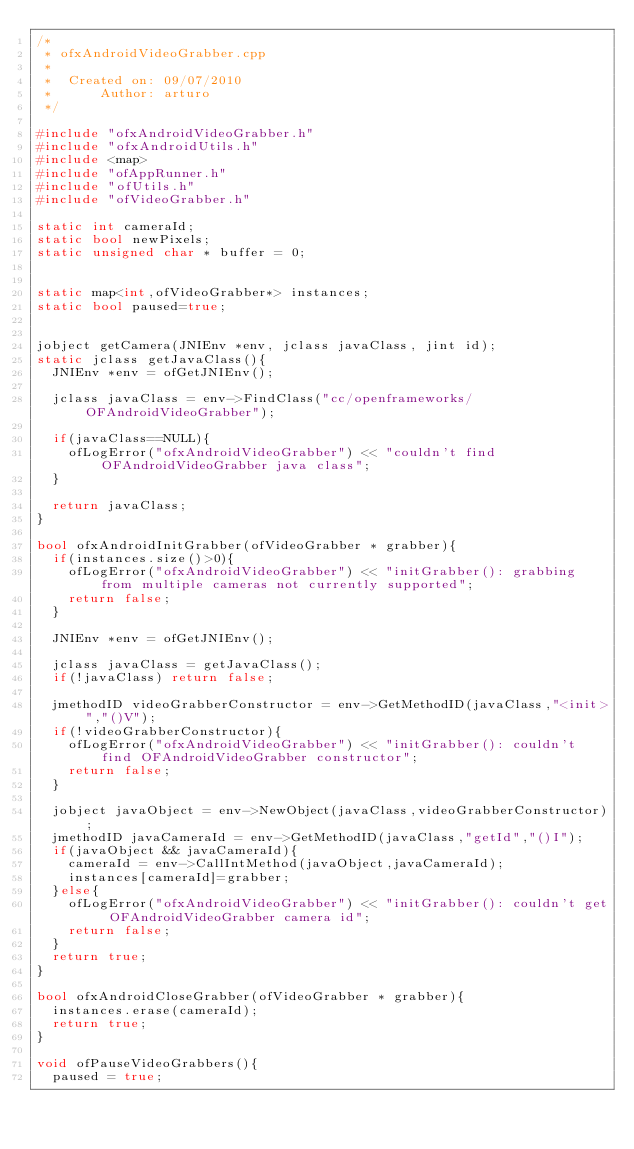Convert code to text. <code><loc_0><loc_0><loc_500><loc_500><_C++_>/*
 * ofxAndroidVideoGrabber.cpp
 *
 *  Created on: 09/07/2010
 *      Author: arturo
 */

#include "ofxAndroidVideoGrabber.h"
#include "ofxAndroidUtils.h"
#include <map>
#include "ofAppRunner.h"
#include "ofUtils.h"
#include "ofVideoGrabber.h"

static int cameraId;
static bool newPixels;
static unsigned char * buffer = 0;


static map<int,ofVideoGrabber*> instances;
static bool paused=true;


jobject getCamera(JNIEnv *env, jclass javaClass, jint id);
static jclass getJavaClass(){
	JNIEnv *env = ofGetJNIEnv();

	jclass javaClass = env->FindClass("cc/openframeworks/OFAndroidVideoGrabber");

	if(javaClass==NULL){
		ofLogError("ofxAndroidVideoGrabber") << "couldn't find OFAndroidVideoGrabber java class";
	}

	return javaClass;
}

bool ofxAndroidInitGrabber(ofVideoGrabber * grabber){
	if(instances.size()>0){
		ofLogError("ofxAndroidVideoGrabber") << "initGrabber(): grabbing from multiple cameras not currently supported";
		return false;
	}

	JNIEnv *env = ofGetJNIEnv();

	jclass javaClass = getJavaClass();
	if(!javaClass) return false;

	jmethodID videoGrabberConstructor = env->GetMethodID(javaClass,"<init>","()V");
	if(!videoGrabberConstructor){
		ofLogError("ofxAndroidVideoGrabber") << "initGrabber(): couldn't find OFAndroidVideoGrabber constructor";
		return false;
	}

	jobject javaObject = env->NewObject(javaClass,videoGrabberConstructor);
	jmethodID javaCameraId = env->GetMethodID(javaClass,"getId","()I");
	if(javaObject && javaCameraId){
		cameraId = env->CallIntMethod(javaObject,javaCameraId);
		instances[cameraId]=grabber;
	}else{
		ofLogError("ofxAndroidVideoGrabber") << "initGrabber(): couldn't get OFAndroidVideoGrabber camera id";
		return false;
	}
	return true;
}

bool ofxAndroidCloseGrabber(ofVideoGrabber * grabber){
	instances.erase(cameraId);
	return true;
}

void ofPauseVideoGrabbers(){
	paused = true;</code> 